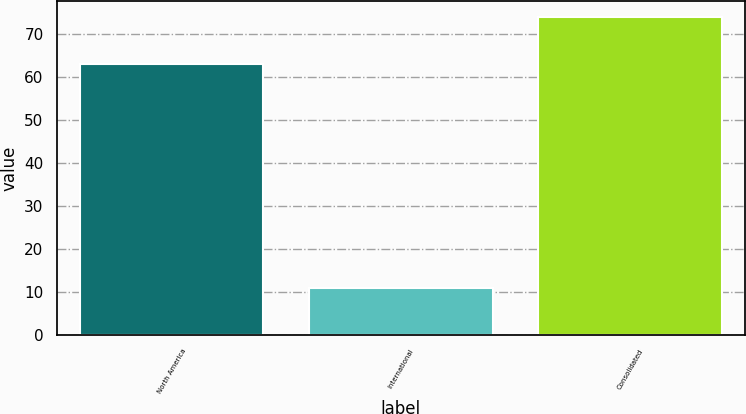Convert chart. <chart><loc_0><loc_0><loc_500><loc_500><bar_chart><fcel>North America<fcel>International<fcel>Consolidated<nl><fcel>63<fcel>11<fcel>74<nl></chart> 